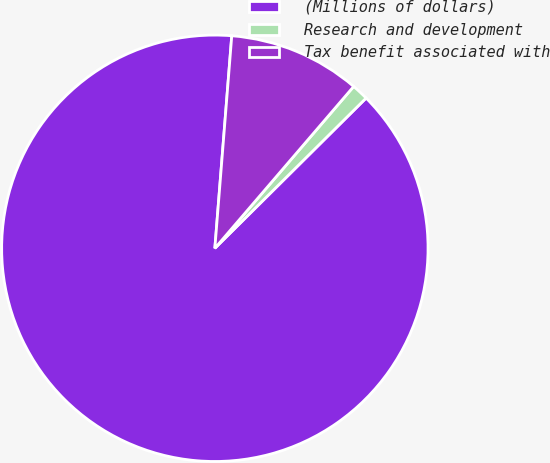Convert chart to OTSL. <chart><loc_0><loc_0><loc_500><loc_500><pie_chart><fcel>(Millions of dollars)<fcel>Research and development<fcel>Tax benefit associated with<nl><fcel>88.71%<fcel>1.27%<fcel>10.02%<nl></chart> 